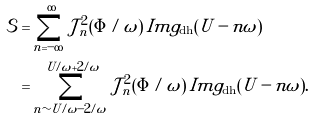Convert formula to latex. <formula><loc_0><loc_0><loc_500><loc_500>\mathcal { S } & = \sum _ { n = - \infty } ^ { \infty } \mathcal { J } _ { n } ^ { 2 } ( \Phi / \omega ) \, I m g _ { \text {dh} } ( U - n \omega ) \\ & = \sum _ { n \sim U / \omega - 2 / \omega } ^ { U / \omega + 2 / \omega } \mathcal { J } _ { n } ^ { 2 } ( \Phi / \omega ) \, I m g _ { \text {dh} } ( U - n \omega ) .</formula> 